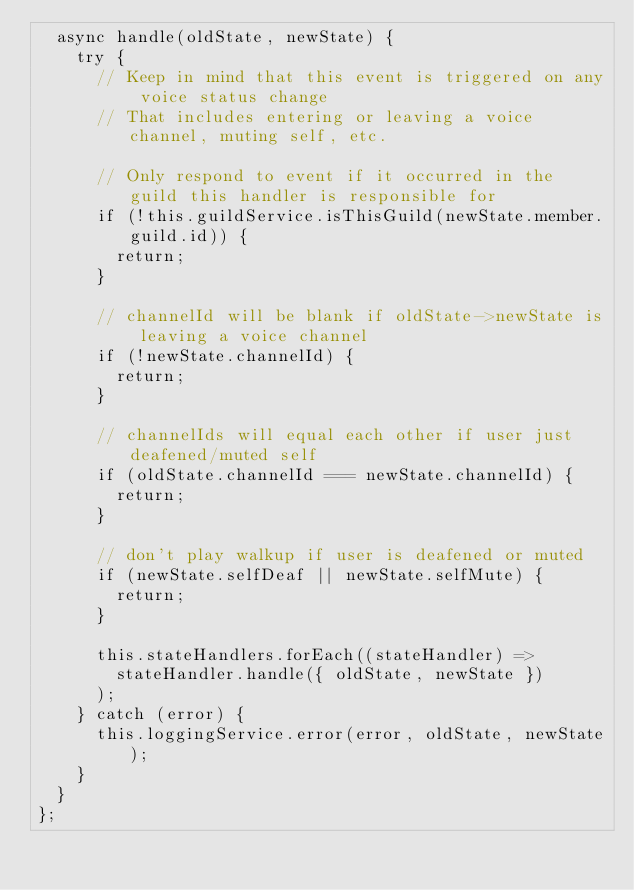<code> <loc_0><loc_0><loc_500><loc_500><_JavaScript_>  async handle(oldState, newState) {
    try {
      // Keep in mind that this event is triggered on any voice status change
      // That includes entering or leaving a voice channel, muting self, etc.

      // Only respond to event if it occurred in the guild this handler is responsible for
      if (!this.guildService.isThisGuild(newState.member.guild.id)) {
        return;
      }

      // channelId will be blank if oldState->newState is leaving a voice channel
      if (!newState.channelId) {
        return;
      }

      // channelIds will equal each other if user just deafened/muted self
      if (oldState.channelId === newState.channelId) {
        return;
      }

      // don't play walkup if user is deafened or muted
      if (newState.selfDeaf || newState.selfMute) {
        return;
      }

      this.stateHandlers.forEach((stateHandler) =>
        stateHandler.handle({ oldState, newState })
      );
    } catch (error) {
      this.loggingService.error(error, oldState, newState);
    }
  }
};
</code> 